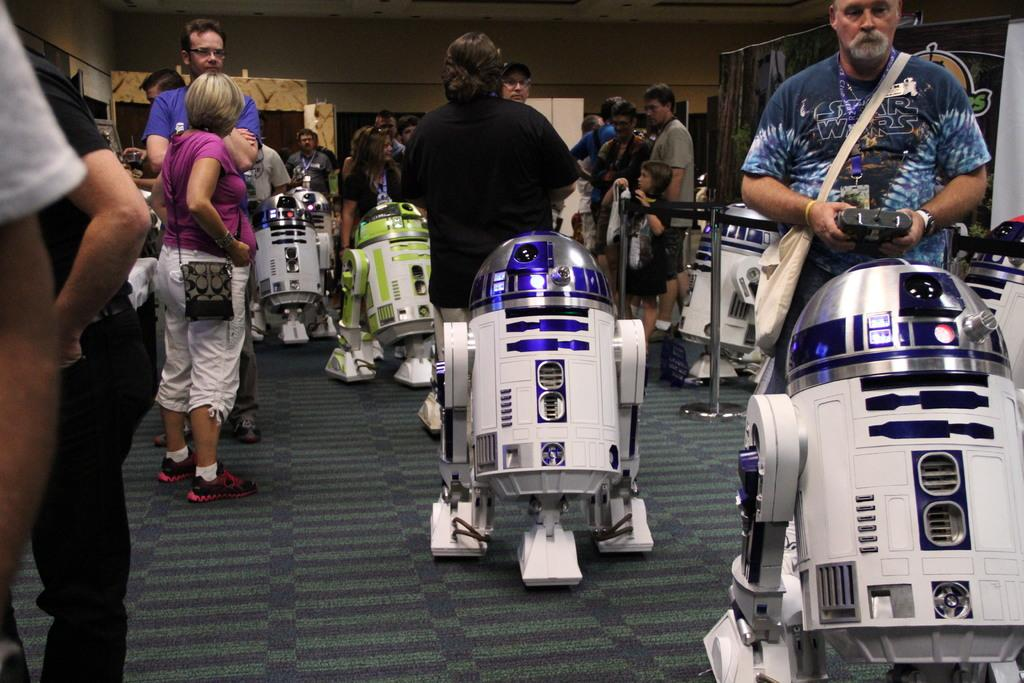What is on the floor in the image? There is a carpet on the floor in the image. What else can be seen in the image besides the carpet? There are people standing in the image, as well as robots. What is the background of the image? There is a wall in the image. What type of hair can be seen on the robots in the image? There are no robots with hair present in the image, as robots typically do not have hair. 